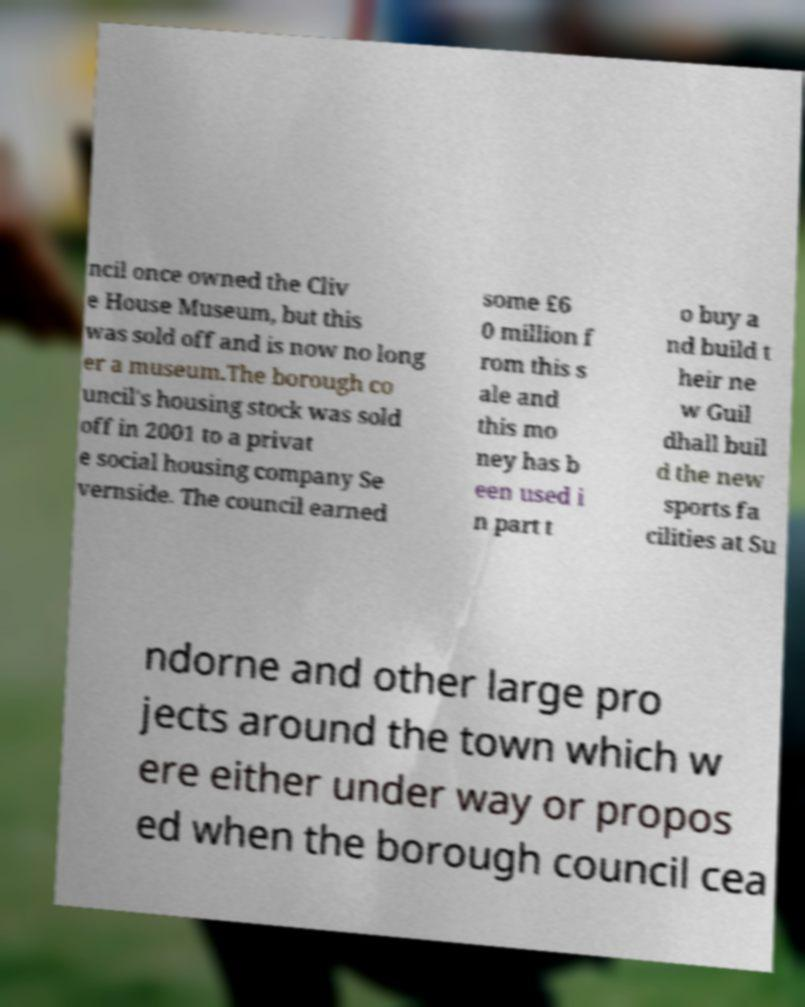Please identify and transcribe the text found in this image. ncil once owned the Cliv e House Museum, but this was sold off and is now no long er a museum.The borough co uncil's housing stock was sold off in 2001 to a privat e social housing company Se vernside. The council earned some £6 0 million f rom this s ale and this mo ney has b een used i n part t o buy a nd build t heir ne w Guil dhall buil d the new sports fa cilities at Su ndorne and other large pro jects around the town which w ere either under way or propos ed when the borough council cea 